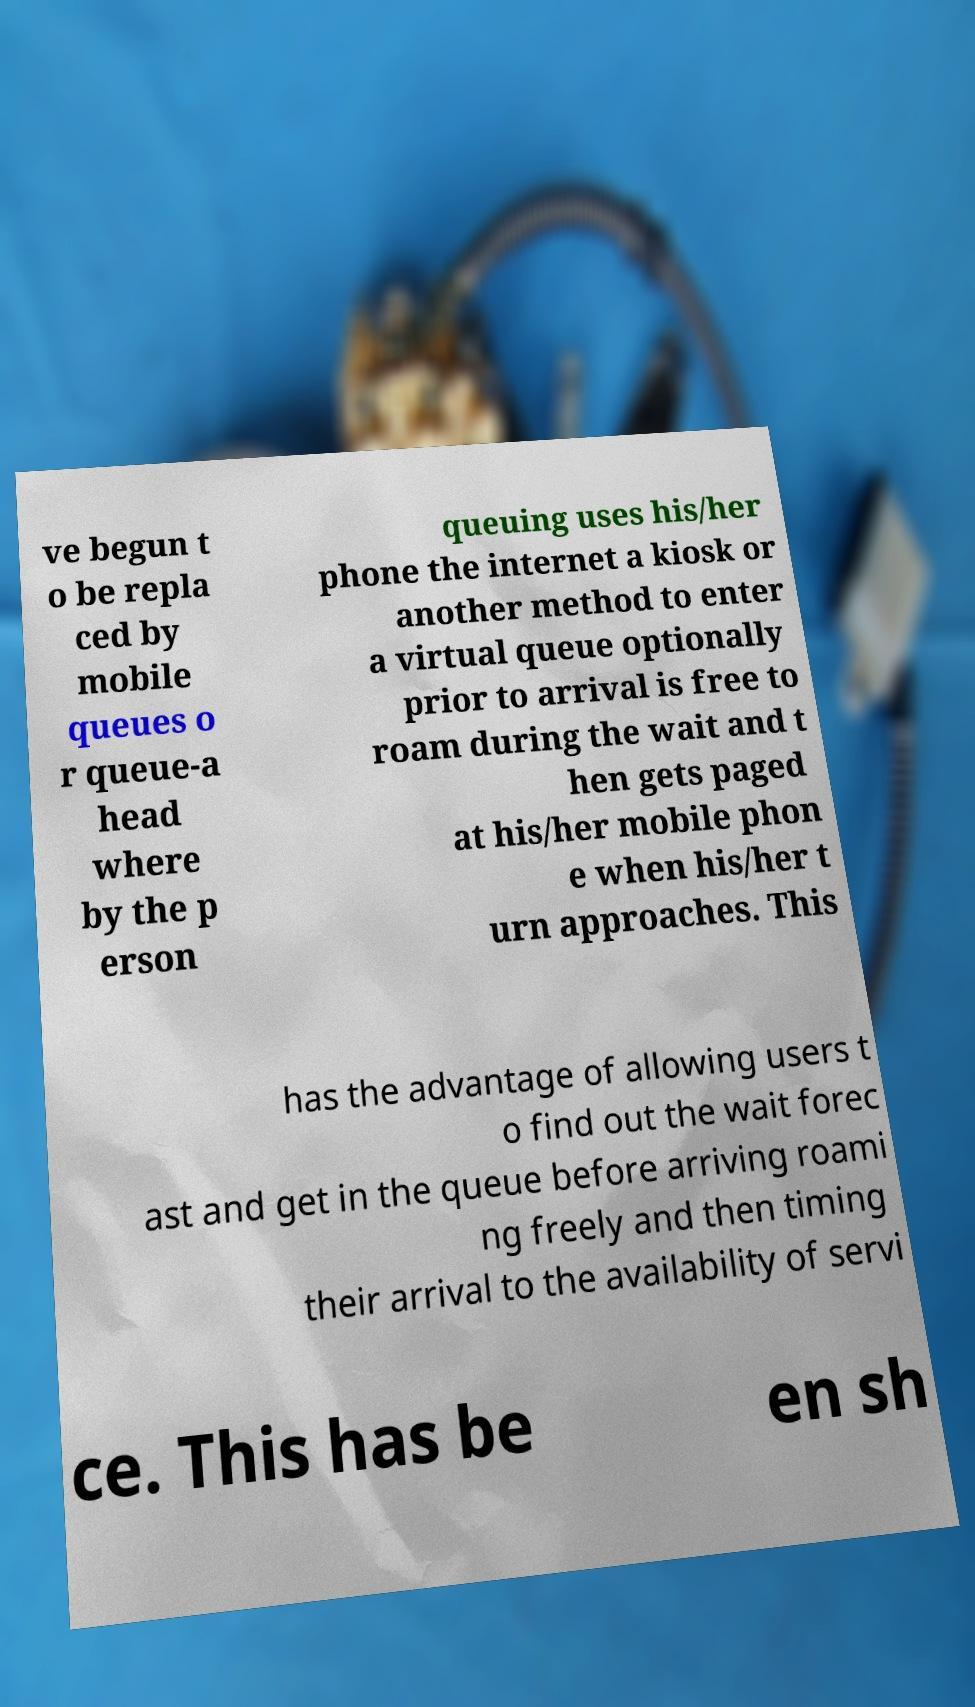There's text embedded in this image that I need extracted. Can you transcribe it verbatim? ve begun t o be repla ced by mobile queues o r queue-a head where by the p erson queuing uses his/her phone the internet a kiosk or another method to enter a virtual queue optionally prior to arrival is free to roam during the wait and t hen gets paged at his/her mobile phon e when his/her t urn approaches. This has the advantage of allowing users t o find out the wait forec ast and get in the queue before arriving roami ng freely and then timing their arrival to the availability of servi ce. This has be en sh 